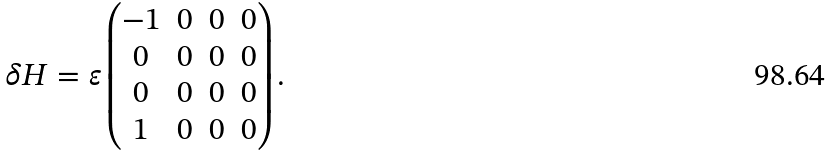<formula> <loc_0><loc_0><loc_500><loc_500>\delta H = \varepsilon \begin{pmatrix} - 1 & 0 & 0 & 0 \\ 0 & 0 & 0 & 0 \\ 0 & 0 & 0 & 0 \\ 1 & 0 & 0 & 0 \\ \end{pmatrix} .</formula> 